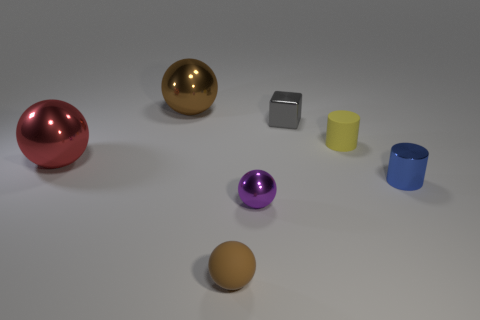What is the size of the thing that is the same color as the rubber sphere?
Provide a short and direct response. Large. Is there a rubber sphere that has the same size as the blue metallic object?
Provide a succinct answer. Yes. There is a large metal thing that is behind the ball that is to the left of the big brown ball; is there a small sphere behind it?
Provide a succinct answer. No. Is the color of the small metal cube the same as the rubber object in front of the shiny cylinder?
Provide a succinct answer. No. The cylinder in front of the object that is left of the brown thing that is behind the tiny brown thing is made of what material?
Make the answer very short. Metal. The big metal thing that is behind the large red ball has what shape?
Your response must be concise. Sphere. What is the size of the purple thing that is the same material as the blue cylinder?
Provide a short and direct response. Small. How many small gray things have the same shape as the yellow thing?
Keep it short and to the point. 0. Do the sphere that is in front of the purple shiny sphere and the cube have the same color?
Your response must be concise. No. What number of small metallic things are behind the tiny purple ball that is right of the big object behind the red thing?
Offer a very short reply. 2. 